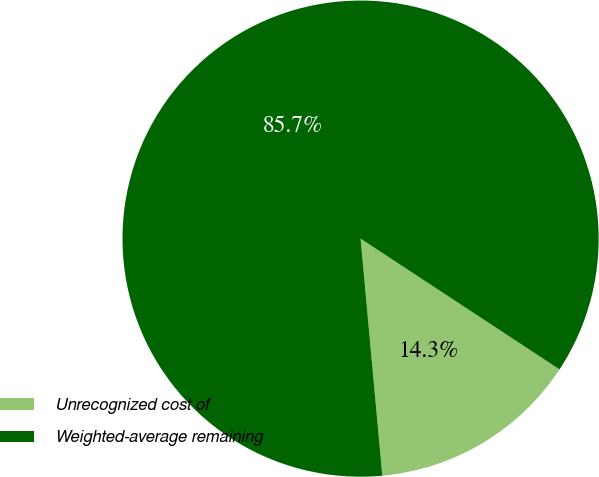Convert chart. <chart><loc_0><loc_0><loc_500><loc_500><pie_chart><fcel>Unrecognized cost of<fcel>Weighted-average remaining<nl><fcel>14.29%<fcel>85.71%<nl></chart> 